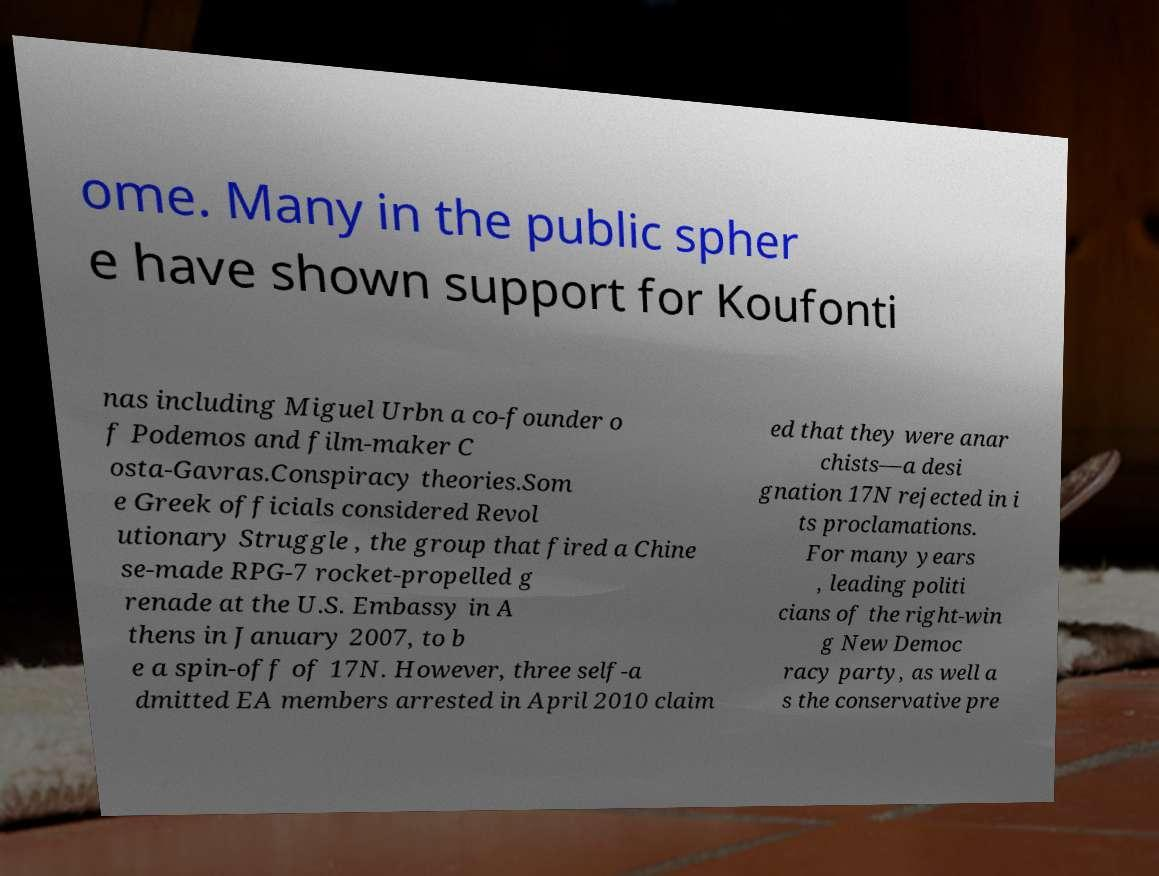Could you assist in decoding the text presented in this image and type it out clearly? ome. Many in the public spher e have shown support for Koufonti nas including Miguel Urbn a co-founder o f Podemos and film-maker C osta-Gavras.Conspiracy theories.Som e Greek officials considered Revol utionary Struggle , the group that fired a Chine se-made RPG-7 rocket-propelled g renade at the U.S. Embassy in A thens in January 2007, to b e a spin-off of 17N. However, three self-a dmitted EA members arrested in April 2010 claim ed that they were anar chists—a desi gnation 17N rejected in i ts proclamations. For many years , leading politi cians of the right-win g New Democ racy party, as well a s the conservative pre 